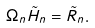<formula> <loc_0><loc_0><loc_500><loc_500>\Omega _ { n } { \tilde { H } } _ { n } = { \tilde { R } } _ { n } .</formula> 